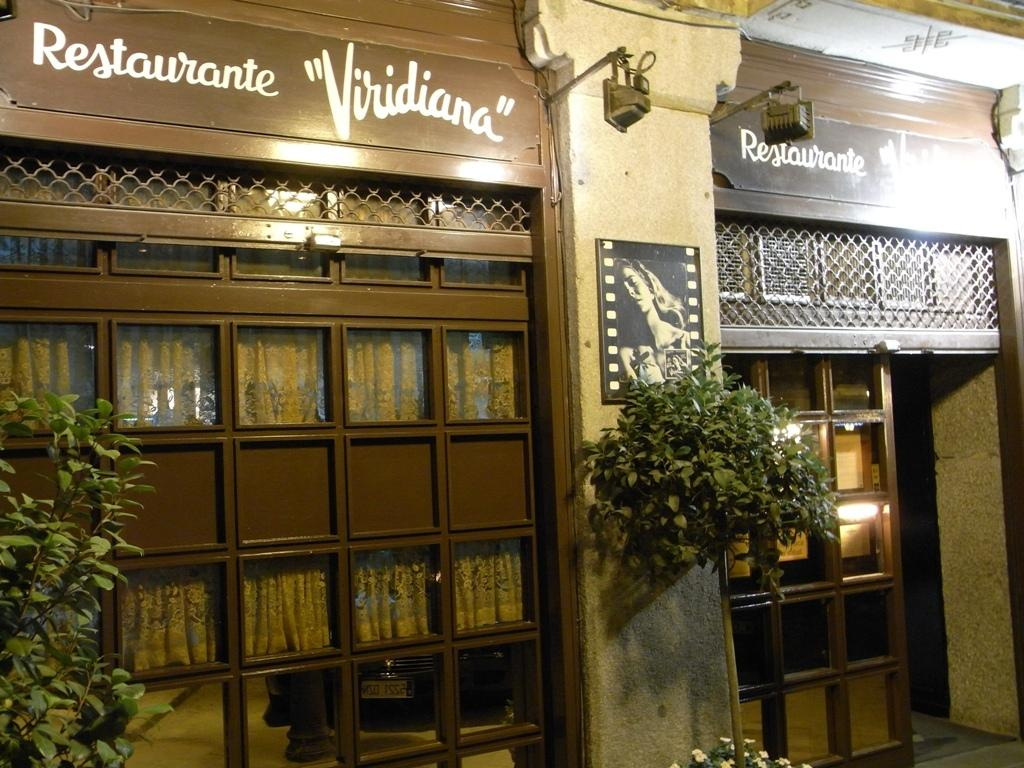<image>
Describe the image concisely. The exterior of the building Restaurante Viridiana at night. 